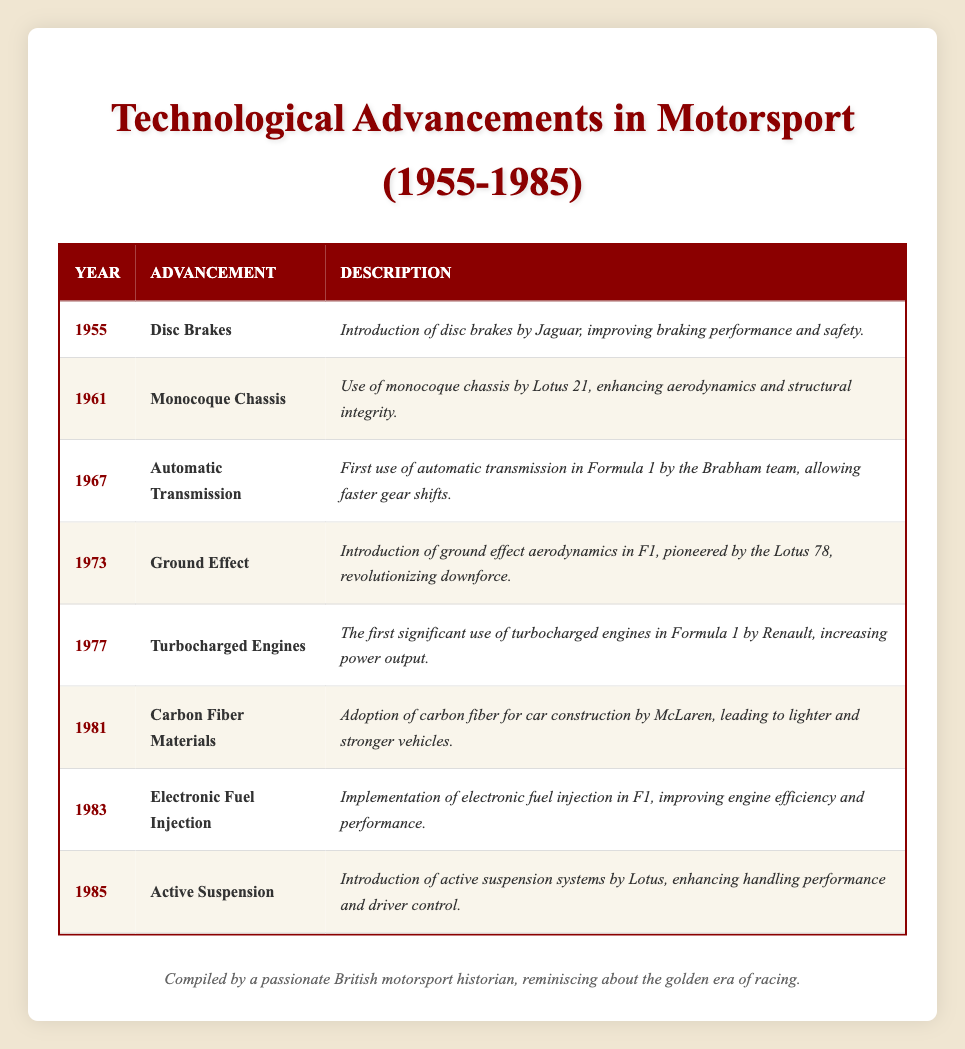What technological advancement was introduced in 1977? By looking at the table, we can see that the year 1977 corresponds to the advancement listed as "Turbocharged Engines."
Answer: Turbocharged Engines Which advancement was the first to implement electronic fuel injection? Referring to the table, the advancement of "Electronic Fuel Injection" was introduced in the year 1983, making it the first in that context.
Answer: 1983 How many years apart were the introductions of disc brakes and monocoque chassis? The introduction of disc brakes was in 1955 and monocoque chassis in 1961. To find the difference, we calculate 1961 - 1955 = 6 years.
Answer: 6 years Is it true that the Lotus team was involved in the introduction of both the monocoque chassis and active suspension? Reviewing the table, we find that Lotus was the team associated with the introduction of the monocoque chassis in 1961 and also introduced active suspension in 1985, confirming the statement is true.
Answer: Yes What was the last technological advancement listed in the table? According to the table, the last entry based on the year is "Active Suspension," which was introduced in 1985.
Answer: Active Suspension Which advancement had a significant focus on increasing engine efficiency, and was it introduced before or after 1980? The "Electronic Fuel Injection" advancement aimed at improving engine efficiency, and as per the table, it was introduced in 1983, which is after 1980.
Answer: After 1980 What is the average year of introduction for all advancements listed in the table? To calculate the average year, we first sum all the years: 1955 + 1961 + 1967 + 1973 + 1977 + 1981 + 1983 + 1985 = 1582. There are 8 advancements, so we divide 1582 by 8, resulting in an average of 197.75. The average year is approximately 1977.
Answer: 1977 Which two advancements contributed to enhancing downforce in motorsport? "Ground Effect" in 1973 and "Turbocharged Engines" in 1977 are the advancements related to enhancing downforce. The former directly deals with aerodynamics while the latter's increased power can contribute to downforce in performance contexts.
Answer: Ground Effect and Turbocharged Engines 